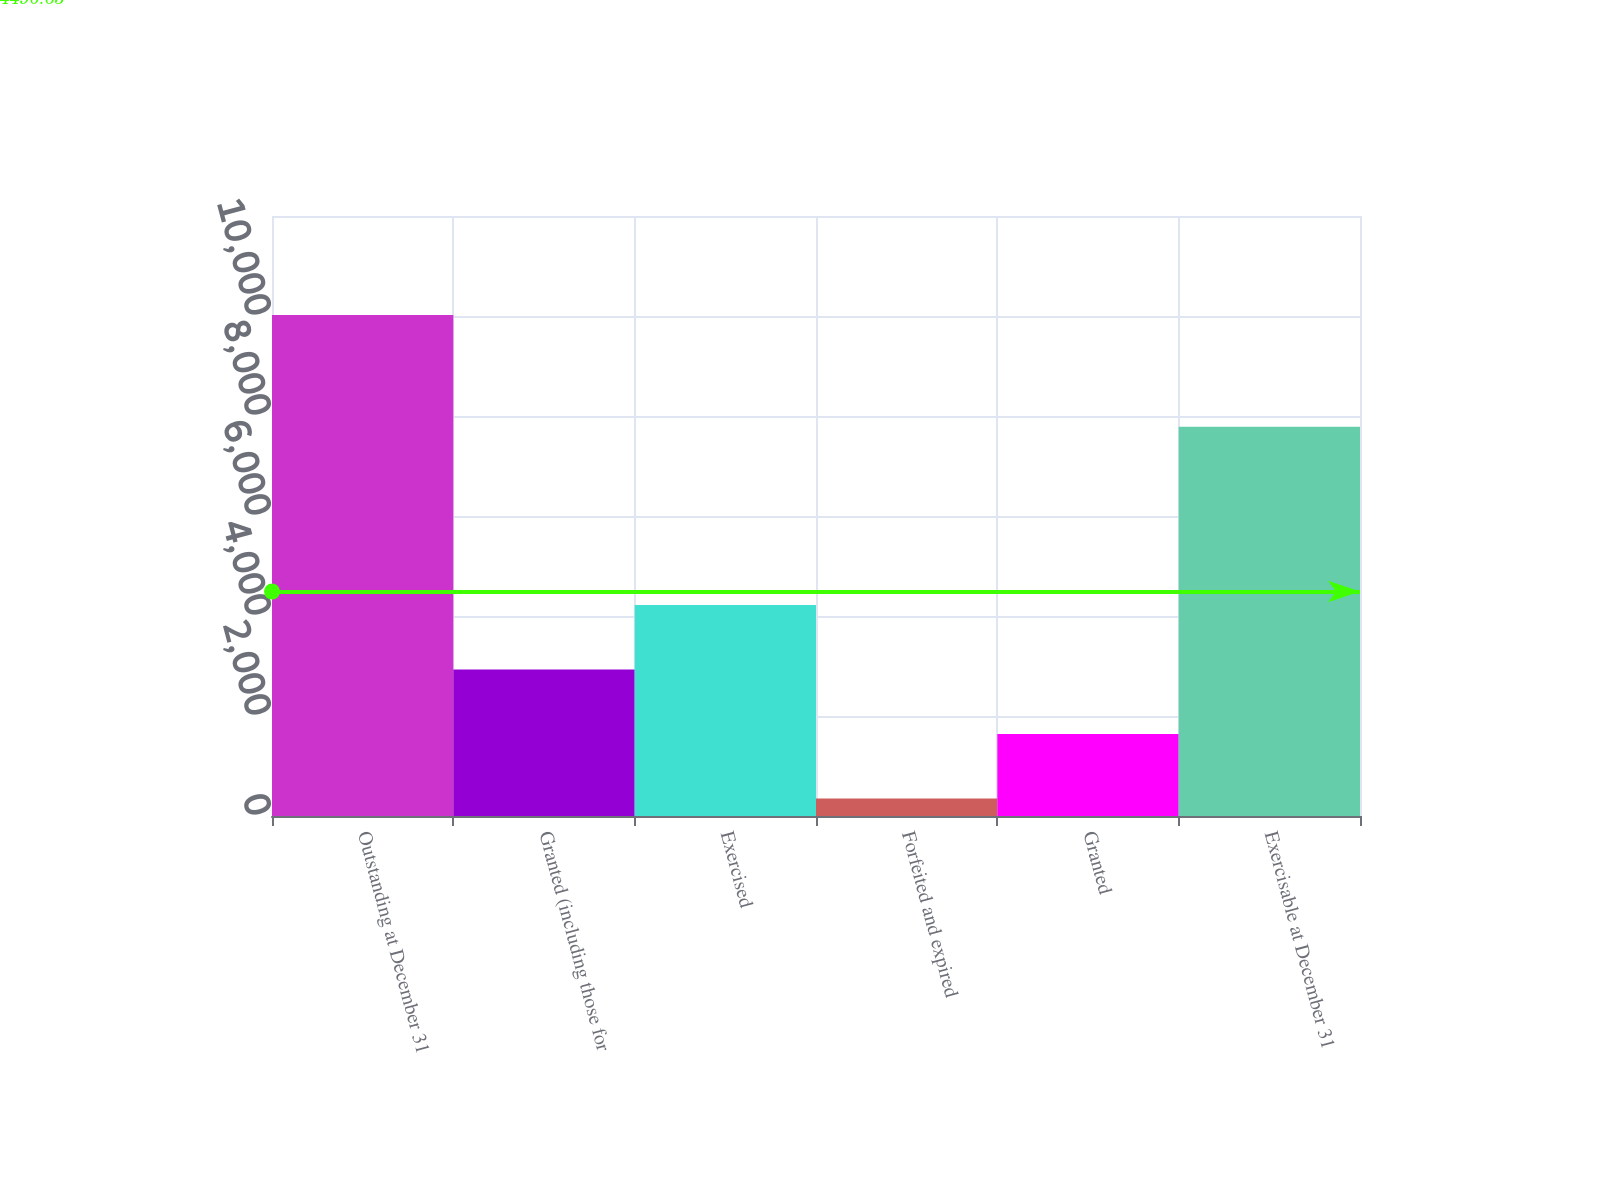Convert chart to OTSL. <chart><loc_0><loc_0><loc_500><loc_500><bar_chart><fcel>Outstanding at December 31<fcel>Granted (including those for<fcel>Exercised<fcel>Forfeited and expired<fcel>Granted<fcel>Exercisable at December 31<nl><fcel>10022<fcel>2928.6<fcel>4218.4<fcel>349<fcel>1638.8<fcel>7787<nl></chart> 